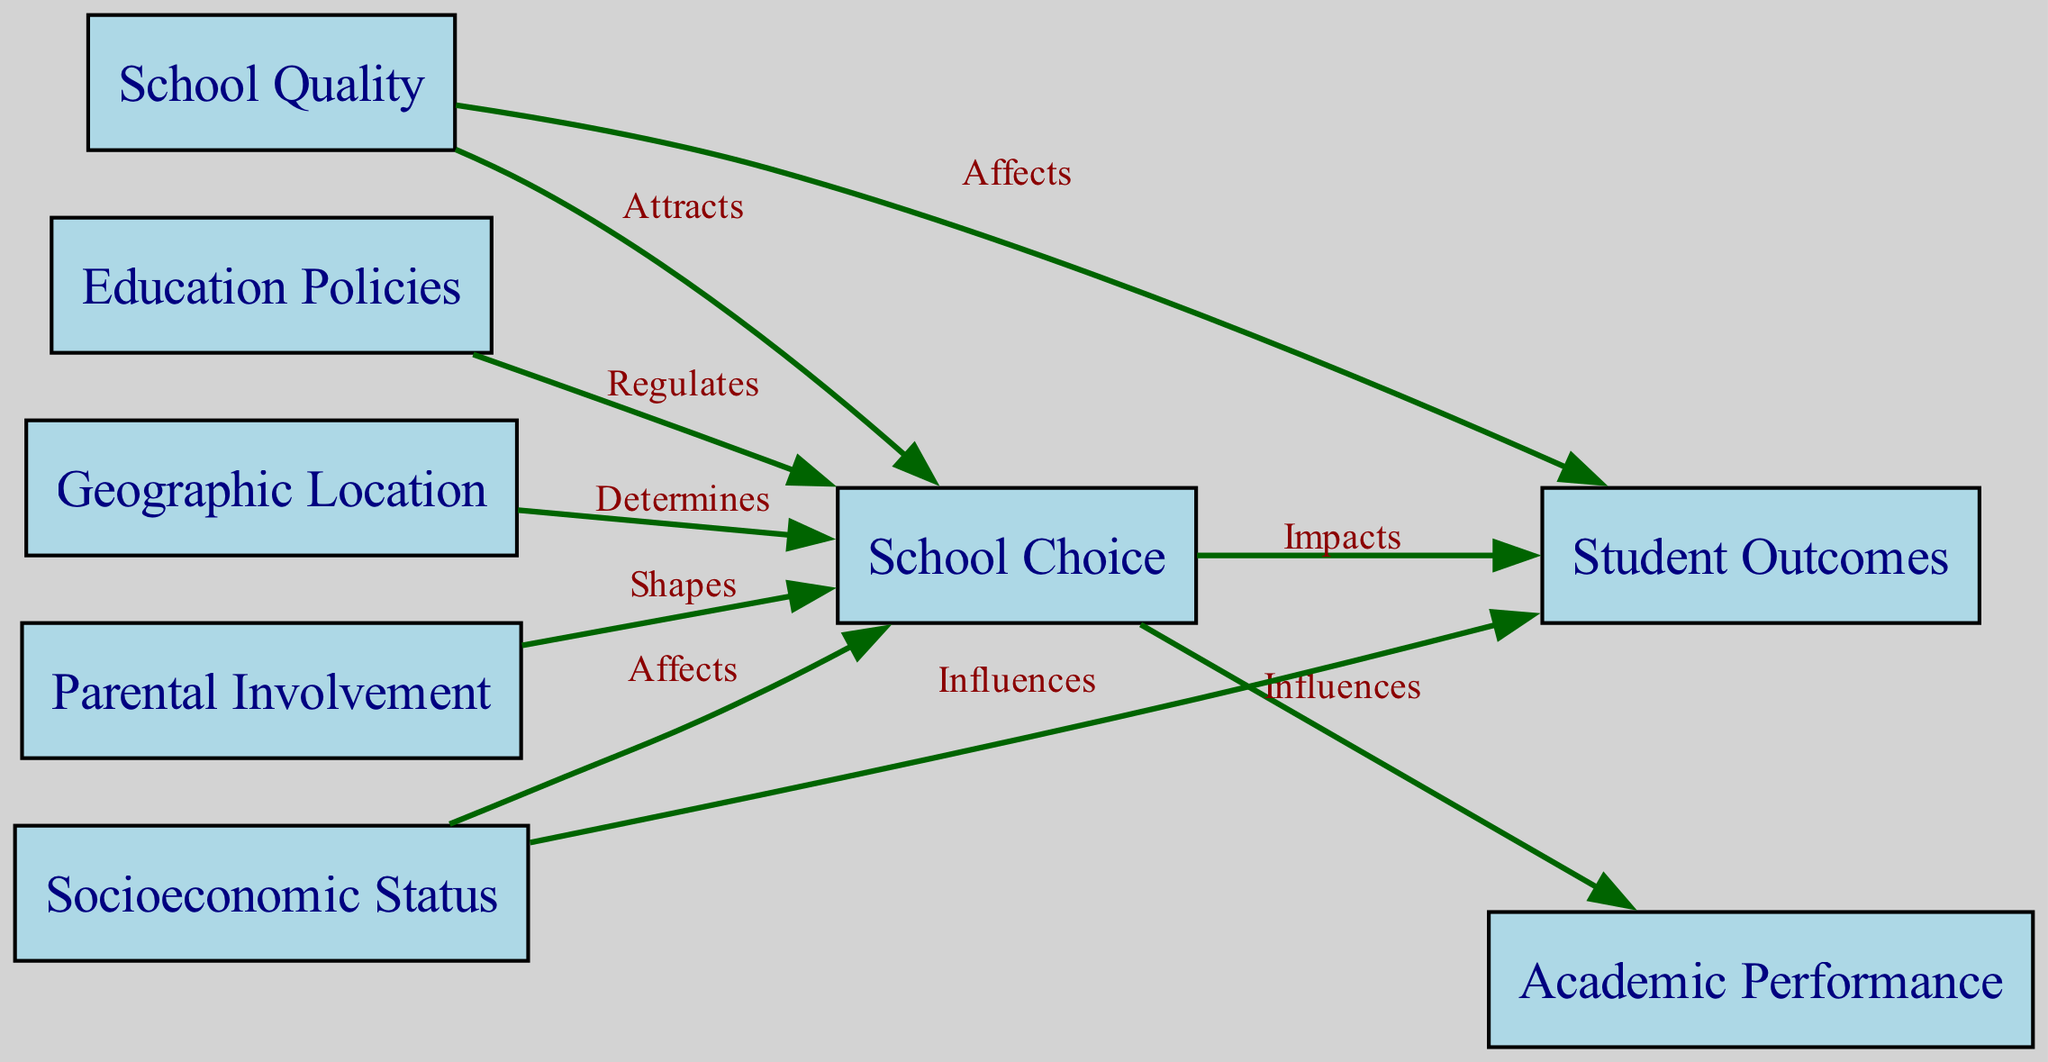What is the main node in the diagram? The main node, which serves as the primary focus of the concept map, is "School Choice". It connects various other factors and outcomes, illustrating its central role in the relationships depicted.
Answer: School Choice How many nodes are present in the diagram? The diagram contains a total of eight nodes, each representing different factors related to school choice and student outcomes. Counting them gives a total of eight distinct nodes: School Choice, Academic Performance, Socioeconomic Status, Geographic Location, School Quality, Parental Involvement, Student Outcomes, and Education Policies.
Answer: 8 Which nodes directly influence "Academic Performance"? The node "School Choice" directly influences "Academic Performance" as indicated by the edge labeled "Influences". This shows the relationship where the choice of school can affect students' academic performance outcomes.
Answer: School Choice What determines "School Choice"? "Geographic Location" is indicated as a factor that determines "School Choice," suggesting that the location of a student's home affects the schools available for selection.
Answer: Geographic Location Which node is regulated by "Education Policies"? The node regulated by "Education Policies" is "School Choice". The edge labeled "Regulates" shows that policies in education shape the options available to parents and students when it comes to choosing a school.
Answer: School Choice How do "Socioeconomic Status" and "School Quality" relate to "Student Outcomes"? Both "Socioeconomic Status" and "School Quality" influence "Student Outcomes". The diagram shows "Socioeconomic Status" as an influencing factor and "School Quality" as an affecting factor, indicating that both contribute to student performance in different ways.
Answer: Influences and Affects What role does "Parental Involvement" play in "School Choice"? "Parental Involvement" shapes "School Choice", suggesting that how engaged parents are in the education process can affect the choices they make about their children's schooling.
Answer: Shapes Which factors influence "Student Outcomes"? "Academic Performance," "School Quality," and "Socioeconomic Status" all influence "Student Outcomes". The connections show that these elements have a direct impact on how students perform academically.
Answer: Academic Performance, School Quality, Socioeconomic Status Which edge indicates the relationship between "School Quality" and "Student Outcomes"? The edge labeled "Affects" indicates the relationship between "School Quality" and "Student Outcomes". This shows that the quality of the school directly impacts the results achieved by students.
Answer: Affects 